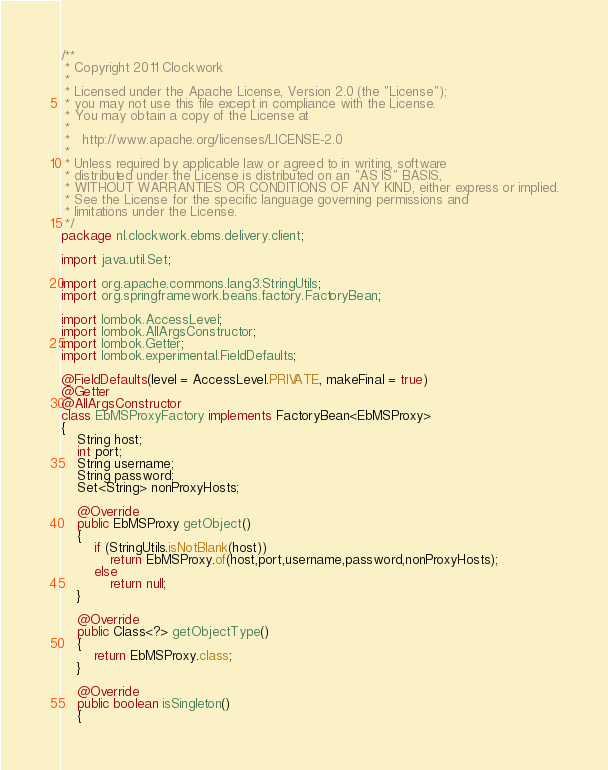Convert code to text. <code><loc_0><loc_0><loc_500><loc_500><_Java_>/**
 * Copyright 2011 Clockwork
 *
 * Licensed under the Apache License, Version 2.0 (the "License");
 * you may not use this file except in compliance with the License.
 * You may obtain a copy of the License at
 *
 *   http://www.apache.org/licenses/LICENSE-2.0
 *
 * Unless required by applicable law or agreed to in writing, software
 * distributed under the License is distributed on an "AS IS" BASIS,
 * WITHOUT WARRANTIES OR CONDITIONS OF ANY KIND, either express or implied.
 * See the License for the specific language governing permissions and
 * limitations under the License.
 */
package nl.clockwork.ebms.delivery.client;

import java.util.Set;

import org.apache.commons.lang3.StringUtils;
import org.springframework.beans.factory.FactoryBean;

import lombok.AccessLevel;
import lombok.AllArgsConstructor;
import lombok.Getter;
import lombok.experimental.FieldDefaults;

@FieldDefaults(level = AccessLevel.PRIVATE, makeFinal = true)
@Getter
@AllArgsConstructor
class EbMSProxyFactory implements FactoryBean<EbMSProxy>
{
	String host;
	int port;
	String username;
	String password;
	Set<String> nonProxyHosts;

	@Override
	public EbMSProxy getObject()
	{
		if (StringUtils.isNotBlank(host))
			return EbMSProxy.of(host,port,username,password,nonProxyHosts);
		else
			return null;
	}

	@Override
	public Class<?> getObjectType()
	{
		return EbMSProxy.class;
	}

	@Override
	public boolean isSingleton()
	{</code> 